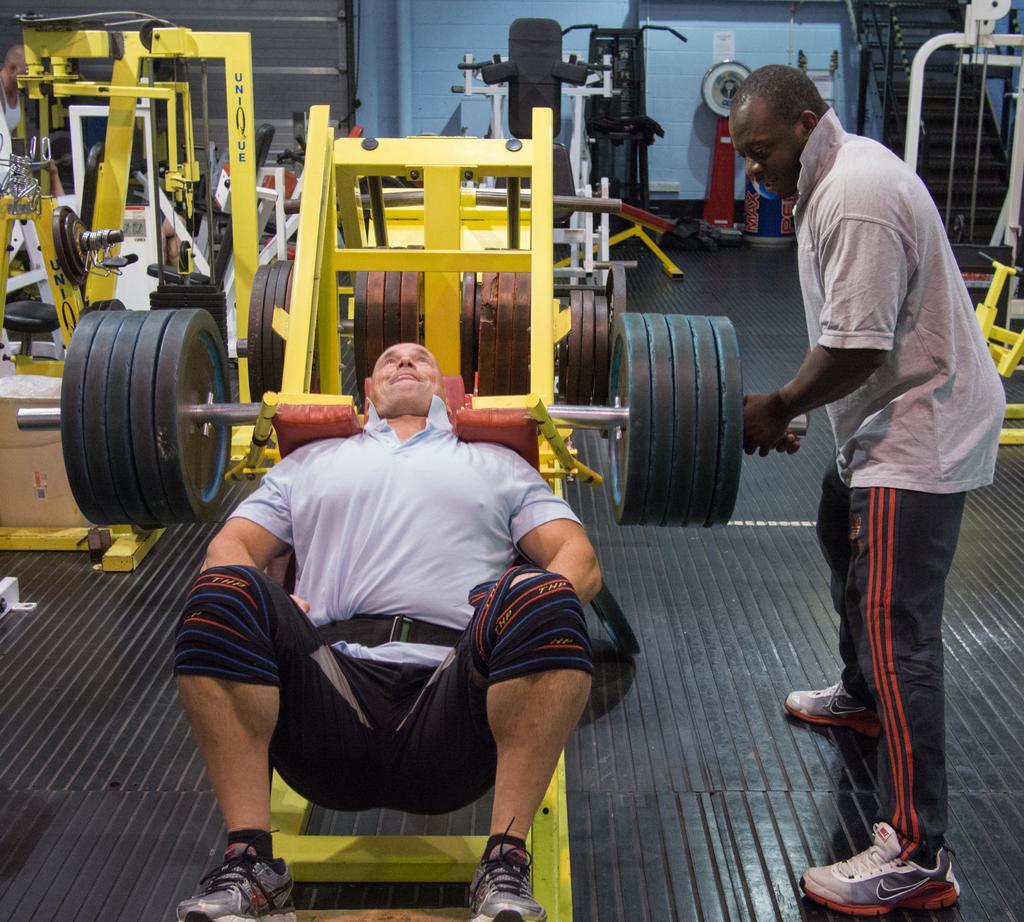In one or two sentences, can you explain what this image depicts? In this picture we can see two men and gym equipment on the floor. In the background we can see steps, walls, pipe and some objects. 